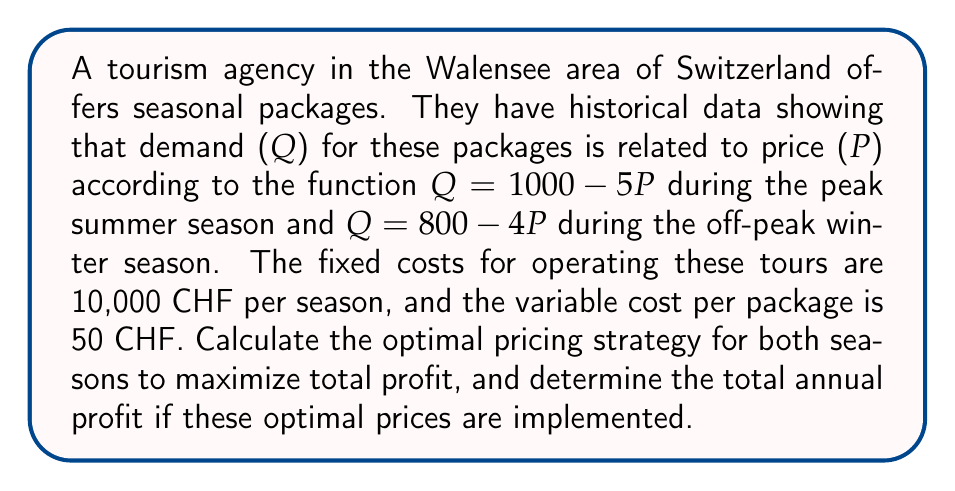Help me with this question. To solve this problem, we'll follow these steps for each season:
1. Set up the profit function
2. Find the derivative of the profit function
3. Set the derivative to zero and solve for P
4. Calculate the optimal quantity and profit

For the peak summer season:
1. Profit function:
   $\pi = PQ - 50Q - 10000$
   $\pi = P(1000 - 5P) - 50(1000 - 5P) - 10000$
   $\pi = 1000P - 5P^2 - 50000 + 250P - 10000$
   $\pi = -5P^2 + 1250P - 60000$

2. Derivative:
   $\frac{d\pi}{dP} = -10P + 1250$

3. Set to zero and solve:
   $-10P + 1250 = 0$
   $P = 125$

4. Optimal quantity and profit:
   $Q = 1000 - 5(125) = 375$
   $\pi = -5(125)^2 + 1250(125) - 60000 = 18,125$ CHF

For the off-peak winter season:
1. Profit function:
   $\pi = PQ - 50Q - 10000$
   $\pi = P(800 - 4P) - 50(800 - 4P) - 10000$
   $\pi = 800P - 4P^2 - 40000 + 200P - 10000$
   $\pi = -4P^2 + 1000P - 50000$

2. Derivative:
   $\frac{d\pi}{dP} = -8P + 1000$

3. Set to zero and solve:
   $-8P + 1000 = 0$
   $P = 125$

4. Optimal quantity and profit:
   $Q = 800 - 4(125) = 300$
   $\pi = -4(125)^2 + 1000(125) - 50000 = 12,500$ CHF

The total annual profit is the sum of both seasons:
$18,125 + 12,500 = 30,625$ CHF
Answer: The optimal pricing strategy is 125 CHF per package for both the peak summer season and the off-peak winter season. The total annual profit when implementing these optimal prices is 30,625 CHF. 